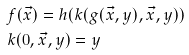Convert formula to latex. <formula><loc_0><loc_0><loc_500><loc_500>& f ( \vec { x } ) = h ( k ( g ( \vec { x } , y ) , \vec { x } , y ) ) \\ & k ( 0 , \vec { x } , y ) = y</formula> 